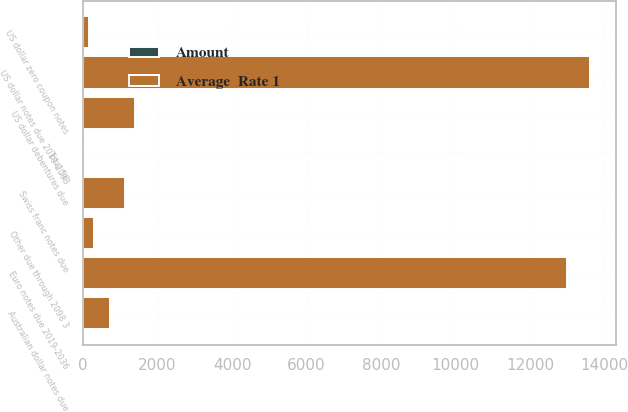Convert chart. <chart><loc_0><loc_0><loc_500><loc_500><stacked_bar_chart><ecel><fcel>US dollar notes due 2019-2093<fcel>US dollar debentures due<fcel>US dollar zero coupon notes<fcel>Australian dollar notes due<fcel>Euro notes due 2019-2036<fcel>Swiss franc notes due<fcel>Other due through 2098 3<fcel>Total 56<nl><fcel>Average  Rate 1<fcel>13619<fcel>1390<fcel>163<fcel>723<fcel>12994<fcel>1128<fcel>282<fcel>8.4<nl><fcel>Amount<fcel>2.6<fcel>5.2<fcel>8.4<fcel>2.2<fcel>0.6<fcel>3.6<fcel>3.4<fcel>1.9<nl></chart> 